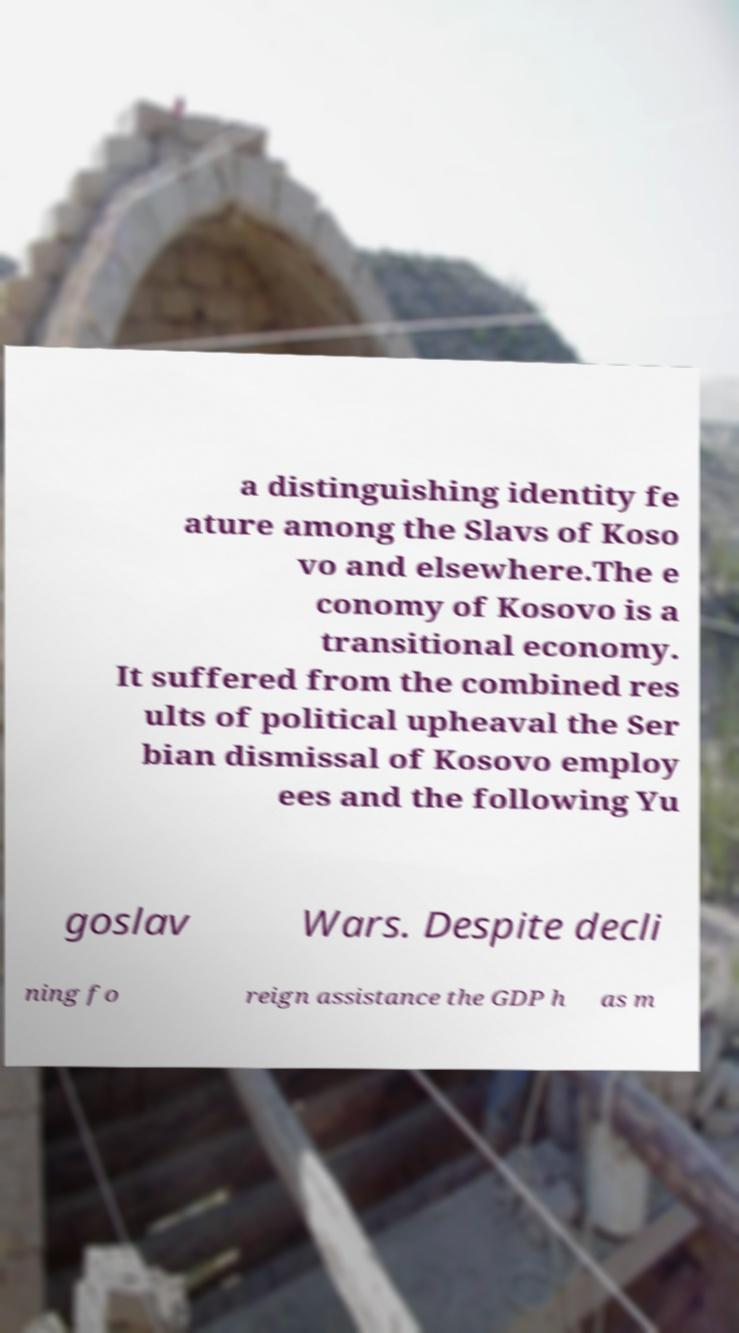Could you assist in decoding the text presented in this image and type it out clearly? a distinguishing identity fe ature among the Slavs of Koso vo and elsewhere.The e conomy of Kosovo is a transitional economy. It suffered from the combined res ults of political upheaval the Ser bian dismissal of Kosovo employ ees and the following Yu goslav Wars. Despite decli ning fo reign assistance the GDP h as m 